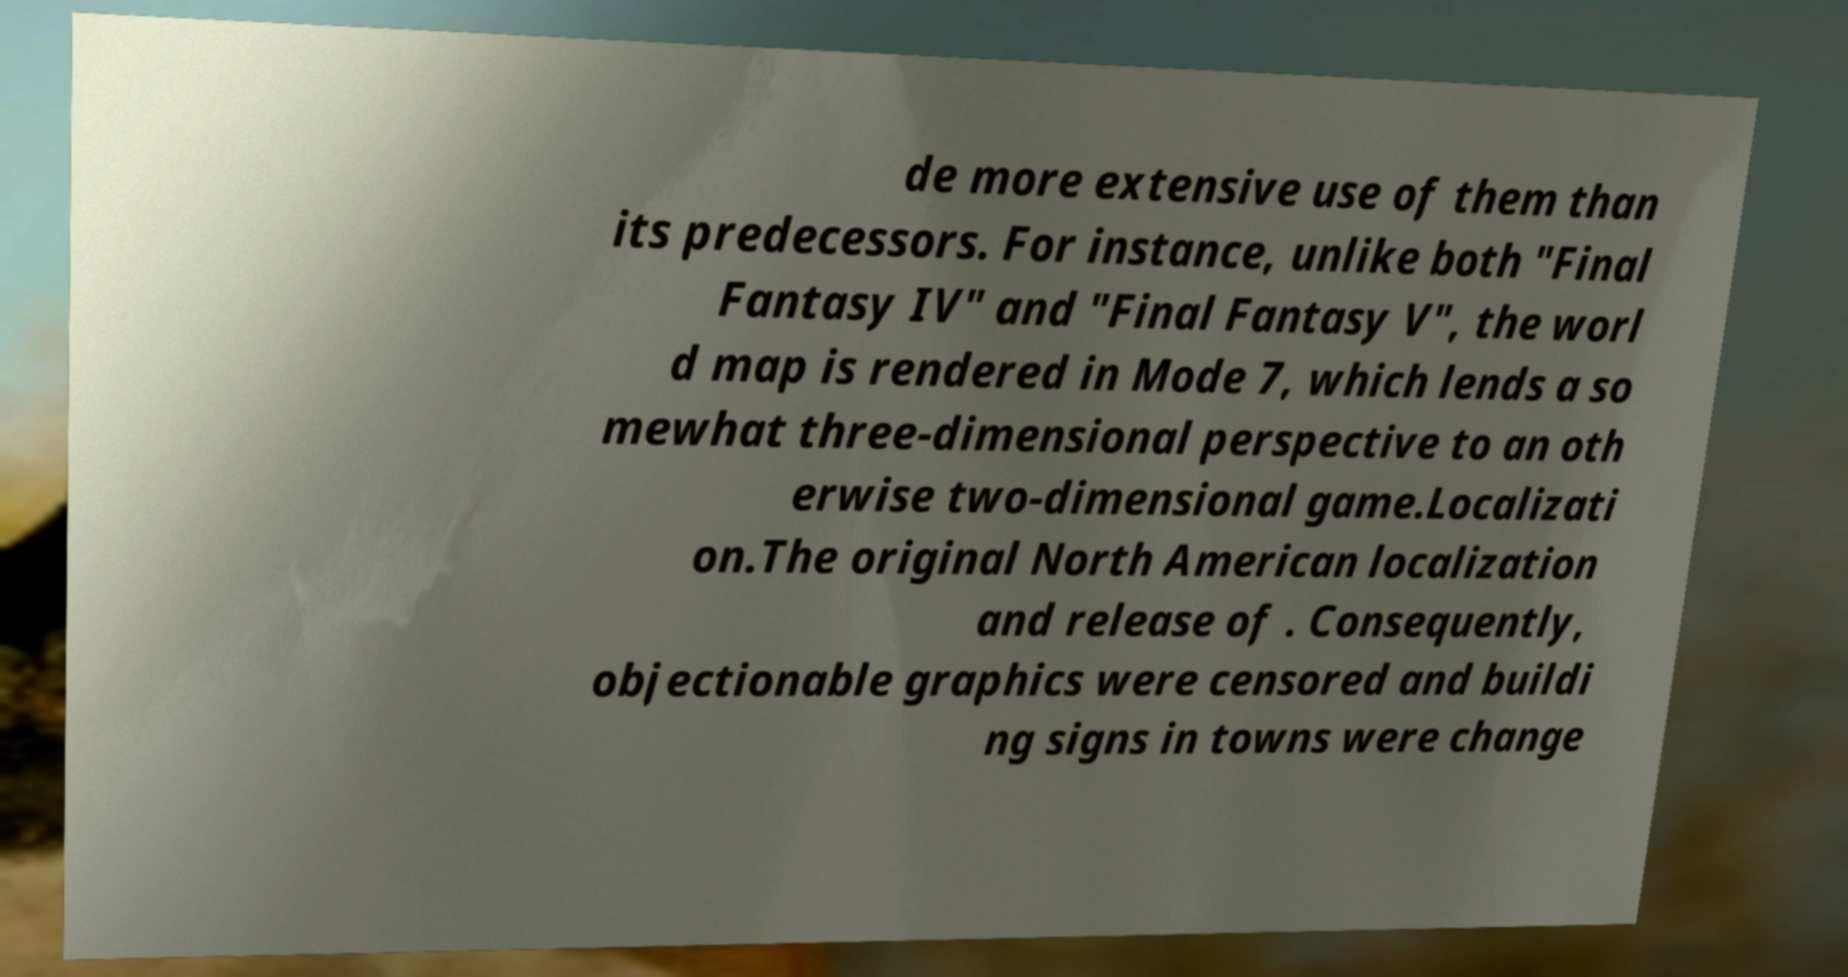Could you assist in decoding the text presented in this image and type it out clearly? de more extensive use of them than its predecessors. For instance, unlike both "Final Fantasy IV" and "Final Fantasy V", the worl d map is rendered in Mode 7, which lends a so mewhat three-dimensional perspective to an oth erwise two-dimensional game.Localizati on.The original North American localization and release of . Consequently, objectionable graphics were censored and buildi ng signs in towns were change 